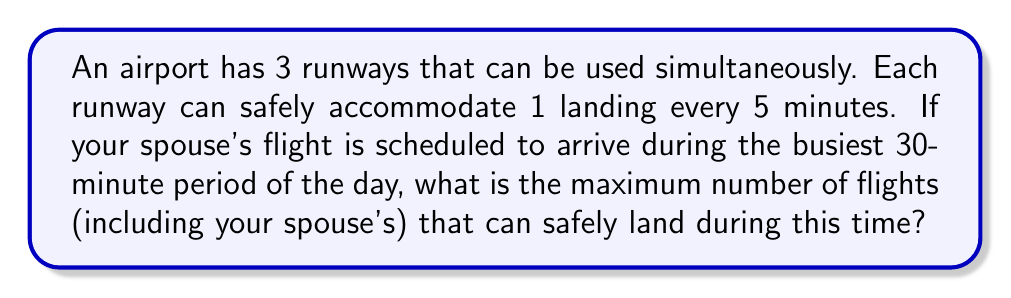Provide a solution to this math problem. Let's approach this step-by-step:

1) First, we need to calculate how many landings can occur on a single runway in 30 minutes:
   
   $$ \text{Landings per runway} = \frac{\text{Time period}}{\text{Time between landings}} = \frac{30 \text{ minutes}}{5 \text{ minutes/landing}} = 6 \text{ landings} $$

2) Now, we have 3 runways that can be used simultaneously. To get the total number of landings, we multiply the number of landings per runway by the number of runways:

   $$ \text{Total landings} = \text{Landings per runway} \times \text{Number of runways} = 6 \times 3 = 18 \text{ landings} $$

3) This result represents the maximum number of flights that can safely land during the 30-minute period, including your spouse's flight.

This problem can be represented as a simple graph where each runway is a node and the edges represent the time slots. Each node would have 6 edges, representing the 6 possible landing slots in the 30-minute period.

[asy]
unitsize(1cm);

draw(circle((0,0),1));
draw(circle((3,0),1));
draw(circle((6,0),1));

label("Runway 1", (0,0));
label("Runway 2", (3,0));
label("Runway 3", (6,0));

for(int i=0; i<6; ++i) {
  draw((cos(pi/3*i), sin(pi/3*i))--(-1+cos(pi/3*i), sin(pi/3*i)), arrow=Arrow());
  draw((3+cos(pi/3*i), sin(pi/3*i))--(2+cos(pi/3*i), sin(pi/3*i)), arrow=Arrow());
  draw((6+cos(pi/3*i), sin(pi/3*i))--(5+cos(pi/3*i), sin(pi/3*i)), arrow=Arrow());
}
[/asy]

Each arrow in the diagram represents a potential landing slot, and there are 18 arrows in total, confirming our calculation.
Answer: The maximum number of flights that can safely land during the busiest 30-minute period is 18. 